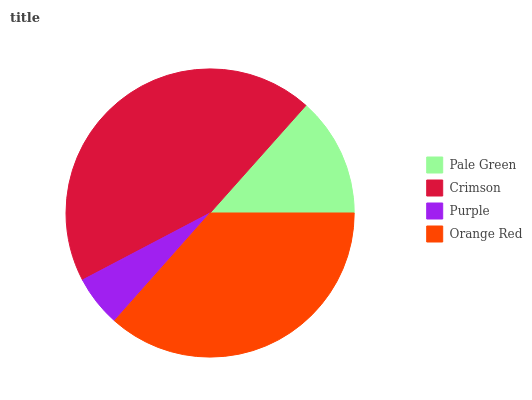Is Purple the minimum?
Answer yes or no. Yes. Is Crimson the maximum?
Answer yes or no. Yes. Is Crimson the minimum?
Answer yes or no. No. Is Purple the maximum?
Answer yes or no. No. Is Crimson greater than Purple?
Answer yes or no. Yes. Is Purple less than Crimson?
Answer yes or no. Yes. Is Purple greater than Crimson?
Answer yes or no. No. Is Crimson less than Purple?
Answer yes or no. No. Is Orange Red the high median?
Answer yes or no. Yes. Is Pale Green the low median?
Answer yes or no. Yes. Is Purple the high median?
Answer yes or no. No. Is Purple the low median?
Answer yes or no. No. 